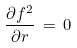<formula> <loc_0><loc_0><loc_500><loc_500>\frac { \partial f ^ { 2 } } { \partial r } \, = \, 0</formula> 